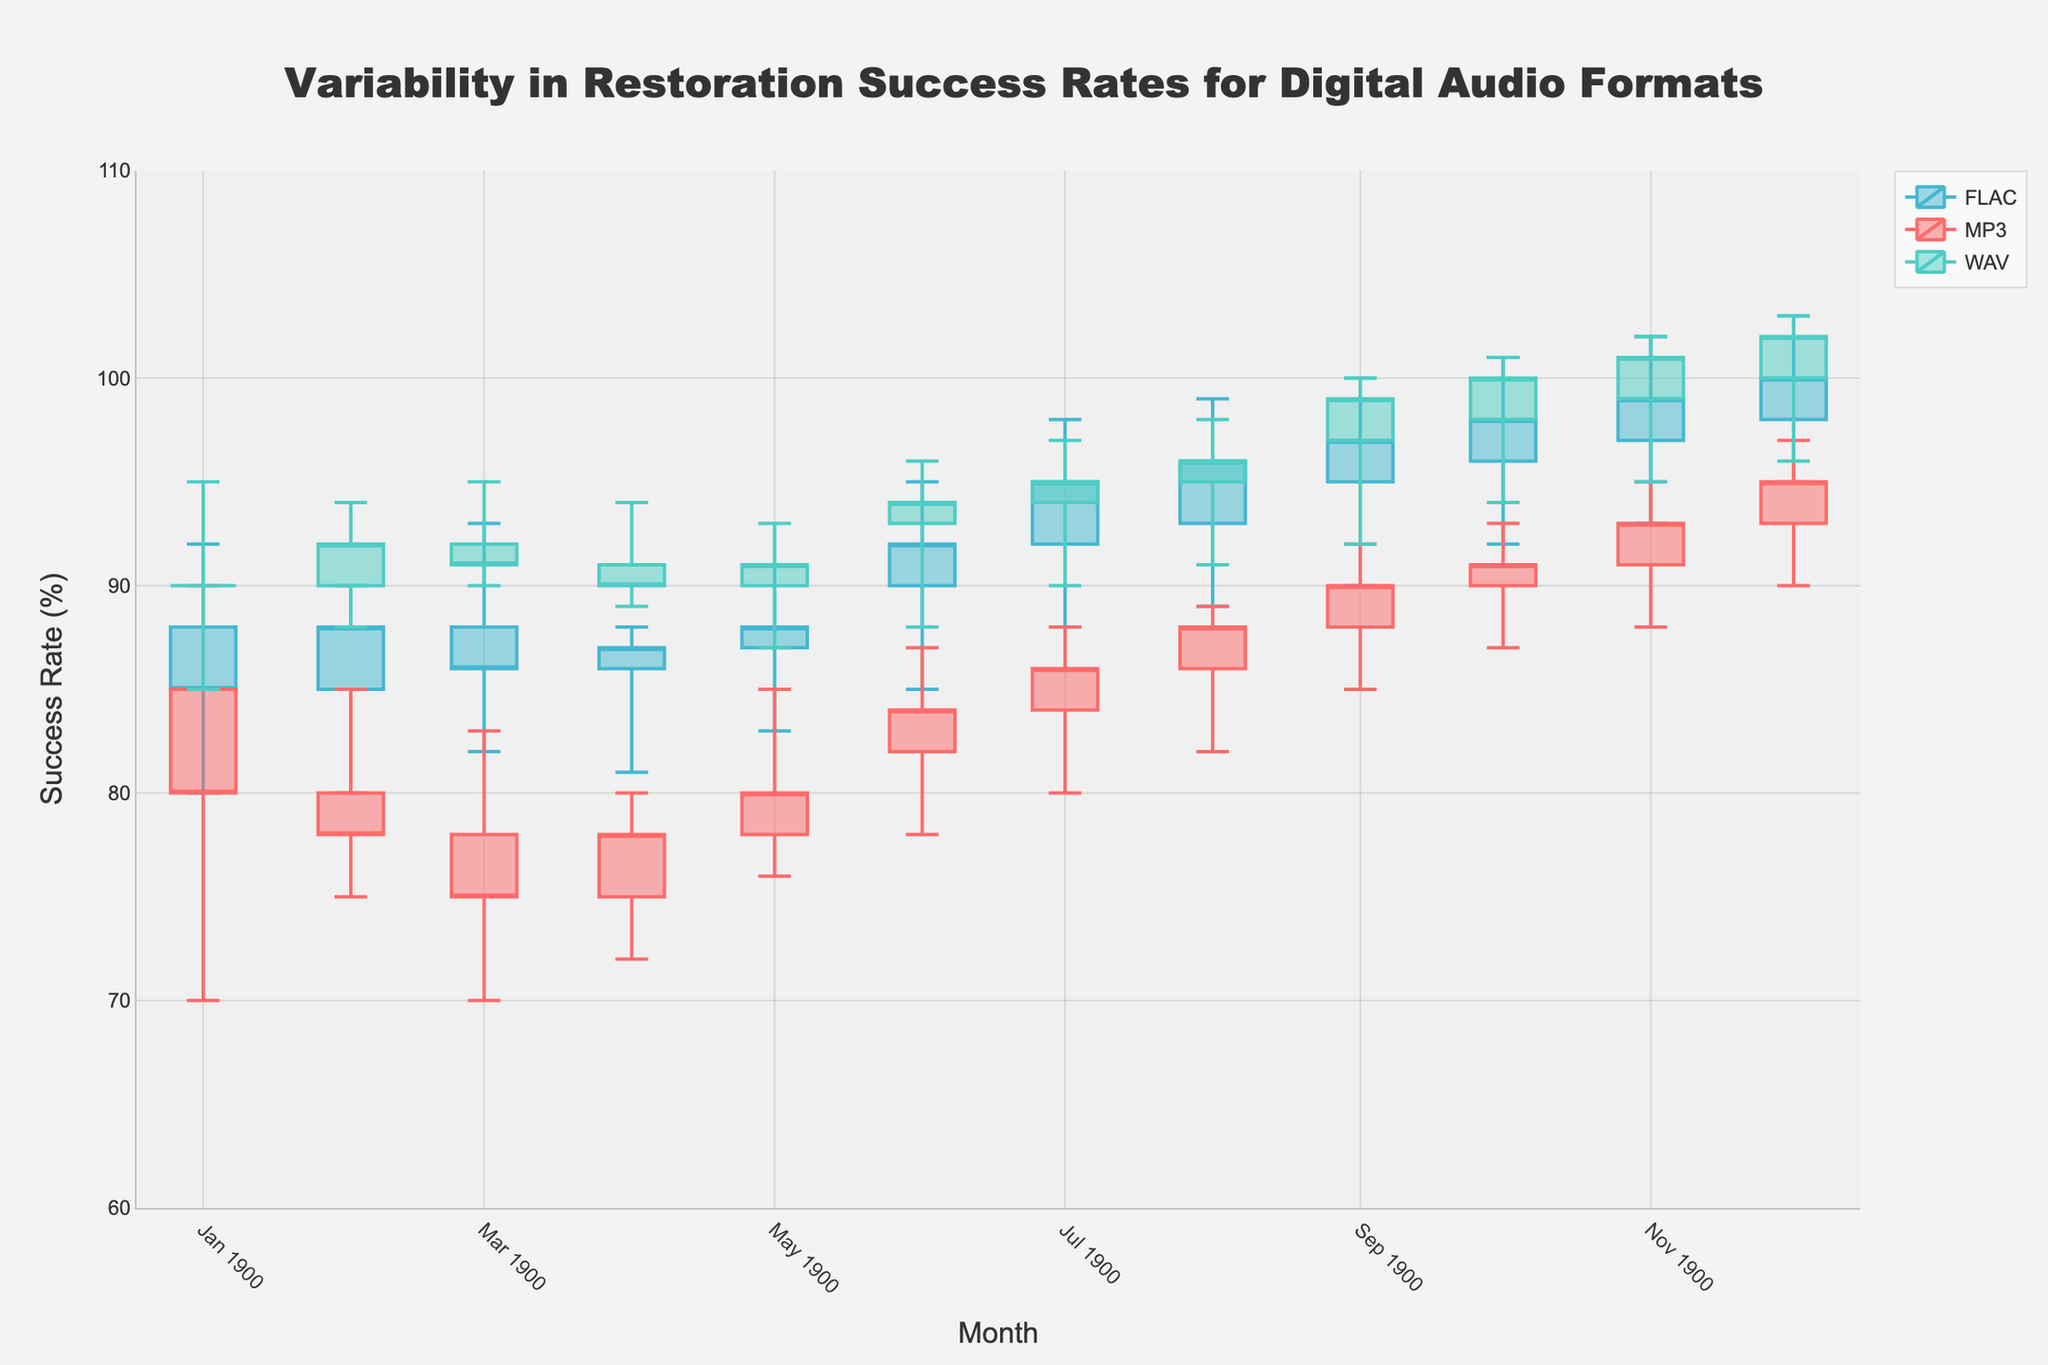What is the title of the plot? The title is displayed prominently at the top of the figure. It provides an overview of what the plot is representing.
Answer: Variability in Restoration Success Rates for Digital Audio Formats What is the y-axis title? The y-axis title is located along the vertical axis of the plot and indicates the metric being measured.
Answer: Success Rate (%) Which month exhibits the highest high value for the FLAC format? To determine this, locate the "FLAC" format on the plot and find the month where the highest value (or "high") is the maximum.
Answer: August, September, October, November, December In which month did MP3 have the highest closing value? Check the closing values for MP3 each month on the plot and identify the month where this value is the highest.
Answer: December Which format shows the most variability in success rates in September? Compare the difference between the high and low values for each format in September. The most variability will be evident in the format with the largest range.
Answer: FLAC What is the range of success rates (high minus low) for WAV in December? Find the high and low values for WAV in December and subtract the low value from the high value to get the range.
Answer: 7 Which format had a continuous increase in closing values from June to August? Check the closing values for each format from June to August and identify the one with consistently increasing values.
Answer: MP3 In which month did WAV have its lowest closing value, and what was the value? Look at the closing values for WAV each month and pinpoint the month with the lowest closing value.
Answer: April, 90 How did the success rates for MP3 change from January to February? Compare the low, open, close, and high values for the MP3 format between January and February to understand the changes.
Answer: Decreased slightly Which format had a higher closing value in August, FLAC or WAV? Check the closing values for both FLAC and WAV in August and compare them to see which is higher.
Answer: WAV 